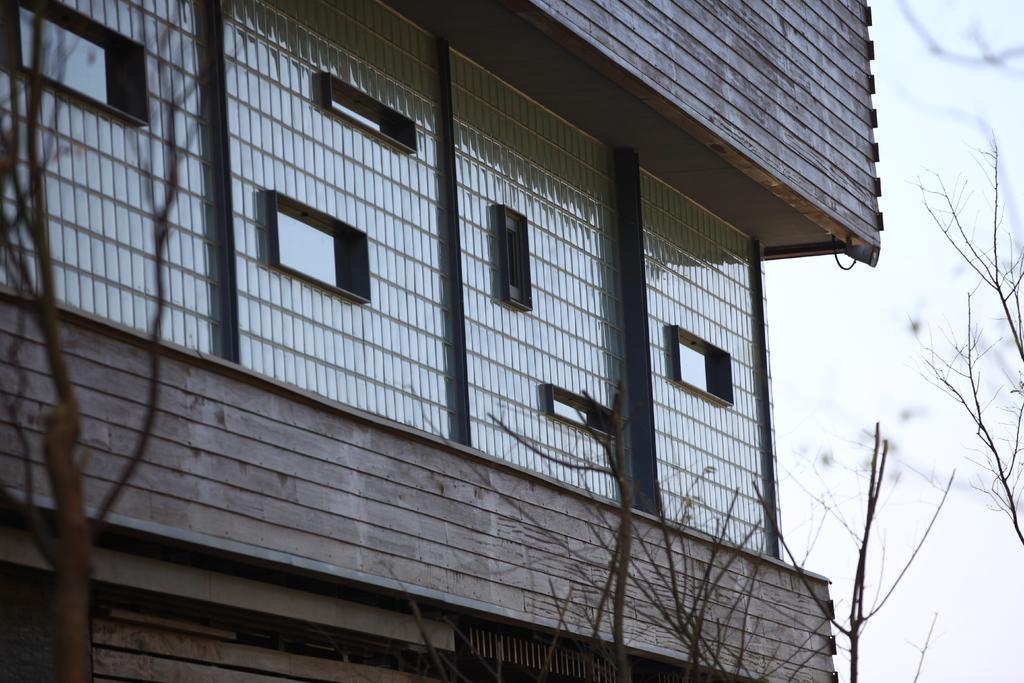Describe this image in one or two sentences. In this image, this looks like a building. I think these are the windows, which looks like a fencing sheet. I can see the branches. This is the sky. 